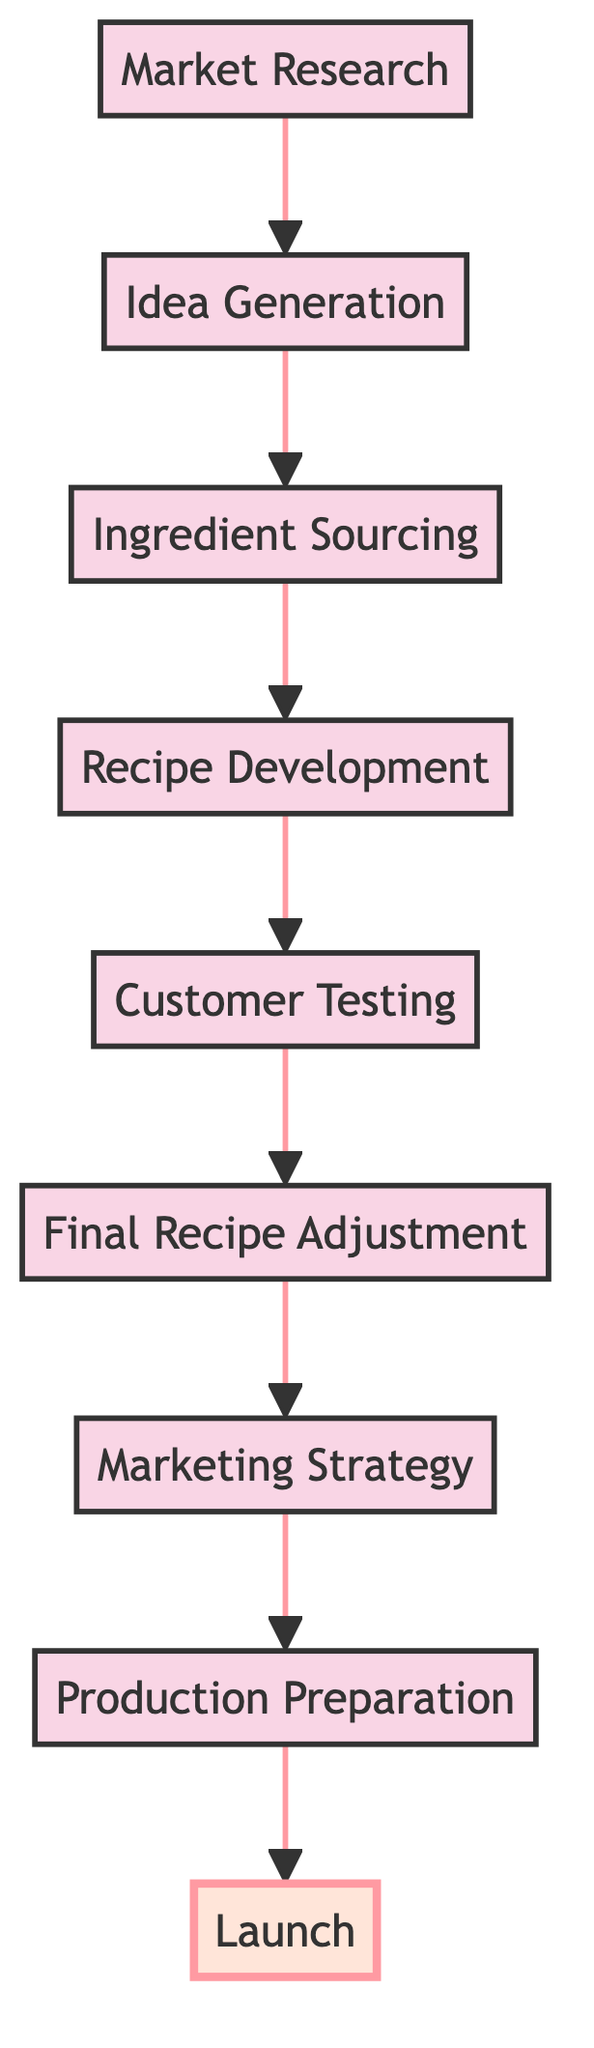What is the last step in the seasonal flavor development process? The final step in the diagram points to the node labeled "Launch." This is the last element in the flow chart, and it signifies the end of the process.
Answer: Launch How many nodes are in the diagram? Counting each of the distinct steps displayed in the diagram, there are a total of nine nodes: Market Research, Idea Generation, Ingredient Sourcing, Recipe Development, Customer Testing, Final Recipe Adjustment, Marketing Strategy, Production Preparation, and Launch.
Answer: Nine What connects 'Recipe Development' to 'Customer Testing'? The arrow drawn from the node 'Recipe Development' leads directly to the node 'Customer Testing'. This indicates a direct relationship in the process flow, showing that after recipe development, customer testing occurs.
Answer: An arrow What comes immediately after 'Final Recipe Adjustment'? Following the flow chart, the node that comes immediately after 'Final Recipe Adjustment' is 'Marketing Strategy'. This shows that once the final adjustments to the recipes are made, the next step is to formulate a marketing strategy.
Answer: Marketing Strategy What node is highlighted in the diagram? The node highlighted in the diagram, indicated by the visual styling, is 'Launch'. This distinction shows it is of particular importance or signifies the conclusion of the entire process.
Answer: Launch Which step requires feedback from customers? 'Customer Testing' is the step where feedback from customers is gathered, as indicated in the diagram. This is the point where the developed flavors are tested with customers for their opinions.
Answer: Customer Testing In which part of the process is ingredient sourcing placed? The node for 'Ingredient Sourcing' is situated in the middle section of the flow chart, logically connected after 'Idea Generation' and before 'Recipe Development.' This indicates its role as a crucial preparatory step.
Answer: Middle section How many steps are there before the 'Launch'? Counting the steps before 'Launch', there are eight steps which include Market Research, Idea Generation, Ingredient Sourcing, Recipe Development, Customer Testing, Final Recipe Adjustment, Marketing Strategy, and Production Preparation.
Answer: Eight 